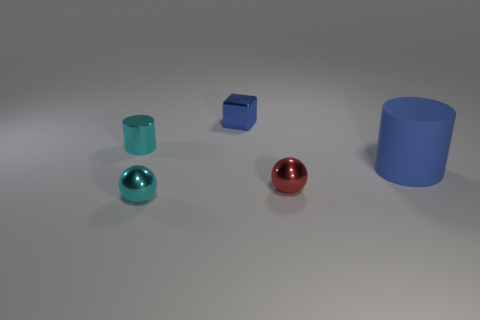Subtract all cubes. How many objects are left? 4 Add 4 shiny things. How many objects exist? 9 Add 2 blue metallic cubes. How many blue metallic cubes exist? 3 Subtract 0 blue balls. How many objects are left? 5 Subtract all metallic objects. Subtract all small cyan balls. How many objects are left? 0 Add 3 cyan metallic balls. How many cyan metallic balls are left? 4 